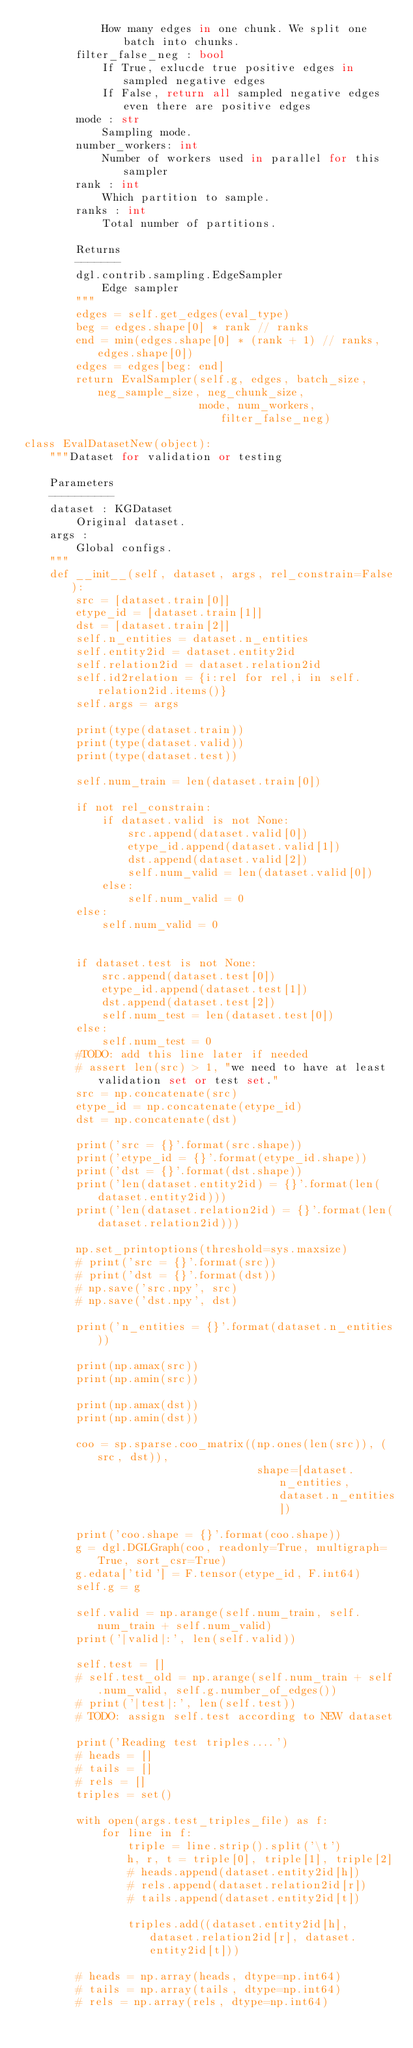<code> <loc_0><loc_0><loc_500><loc_500><_Python_>            How many edges in one chunk. We split one batch into chunks.
        filter_false_neg : bool
            If True, exlucde true positive edges in sampled negative edges
            If False, return all sampled negative edges even there are positive edges
        mode : str
            Sampling mode.
        number_workers: int
            Number of workers used in parallel for this sampler
        rank : int
            Which partition to sample.
        ranks : int
            Total number of partitions.

        Returns
        -------
        dgl.contrib.sampling.EdgeSampler
            Edge sampler
        """
        edges = self.get_edges(eval_type)
        beg = edges.shape[0] * rank // ranks
        end = min(edges.shape[0] * (rank + 1) // ranks, edges.shape[0])
        edges = edges[beg: end]
        return EvalSampler(self.g, edges, batch_size, neg_sample_size, neg_chunk_size,
                           mode, num_workers, filter_false_neg)

class EvalDatasetNew(object):
    """Dataset for validation or testing

    Parameters
    ----------
    dataset : KGDataset
        Original dataset.
    args :
        Global configs.
    """
    def __init__(self, dataset, args, rel_constrain=False):
        src = [dataset.train[0]]
        etype_id = [dataset.train[1]]
        dst = [dataset.train[2]]
        self.n_entities = dataset.n_entities
        self.entity2id = dataset.entity2id
        self.relation2id = dataset.relation2id
        self.id2relation = {i:rel for rel,i in self.relation2id.items()}
        self.args = args

        print(type(dataset.train))
        print(type(dataset.valid))
        print(type(dataset.test))

        self.num_train = len(dataset.train[0])

        if not rel_constrain:
            if dataset.valid is not None:
                src.append(dataset.valid[0])
                etype_id.append(dataset.valid[1])
                dst.append(dataset.valid[2])
                self.num_valid = len(dataset.valid[0])
            else:
                self.num_valid = 0
        else:
            self.num_valid = 0

            
        if dataset.test is not None:
            src.append(dataset.test[0])
            etype_id.append(dataset.test[1])
            dst.append(dataset.test[2])
            self.num_test = len(dataset.test[0])
        else:
            self.num_test = 0
        #TODO: add this line later if needed
        # assert len(src) > 1, "we need to have at least validation set or test set."
        src = np.concatenate(src)
        etype_id = np.concatenate(etype_id)
        dst = np.concatenate(dst)

        print('src = {}'.format(src.shape))
        print('etype_id = {}'.format(etype_id.shape))
        print('dst = {}'.format(dst.shape))
        print('len(dataset.entity2id) = {}'.format(len(dataset.entity2id)))
        print('len(dataset.relation2id) = {}'.format(len(dataset.relation2id)))

        np.set_printoptions(threshold=sys.maxsize)
        # print('src = {}'.format(src))
        # print('dst = {}'.format(dst))
        # np.save('src.npy', src)
        # np.save('dst.npy', dst)
        
        print('n_entities = {}'.format(dataset.n_entities))

        print(np.amax(src))
        print(np.amin(src))

        print(np.amax(dst))
        print(np.amin(dst))

        coo = sp.sparse.coo_matrix((np.ones(len(src)), (src, dst)),
                                    shape=[dataset.n_entities, dataset.n_entities])

        print('coo.shape = {}'.format(coo.shape))
        g = dgl.DGLGraph(coo, readonly=True, multigraph=True, sort_csr=True)
        g.edata['tid'] = F.tensor(etype_id, F.int64)
        self.g = g

        self.valid = np.arange(self.num_train, self.num_train + self.num_valid)
        print('|valid|:', len(self.valid))

        self.test = []
        # self.test_old = np.arange(self.num_train + self.num_valid, self.g.number_of_edges())
        # print('|test|:', len(self.test))
        # TODO: assign self.test according to NEW dataset

        print('Reading test triples....')
        # heads = []
        # tails = []
        # rels = []
        triples = set()
        
        with open(args.test_triples_file) as f:
            for line in f:
                triple = line.strip().split('\t')
                h, r, t = triple[0], triple[1], triple[2]
                # heads.append(dataset.entity2id[h])
                # rels.append(dataset.relation2id[r])
                # tails.append(dataset.entity2id[t])

                triples.add((dataset.entity2id[h], dataset.relation2id[r], dataset.entity2id[t]))

        # heads = np.array(heads, dtype=np.int64)
        # tails = np.array(tails, dtype=np.int64)
        # rels = np.array(rels, dtype=np.int64)</code> 